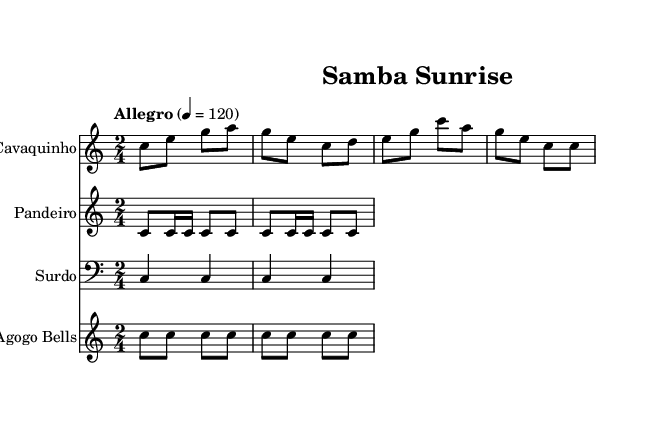What is the key signature of this music? The key signature is C major, which has no sharps or flats.
Answer: C major What is the time signature of this music? The time signature is indicated at the beginning of the score and is 2/4, meaning there are 2 beats per measure and the quarter note gets one beat.
Answer: 2/4 What is the tempo marking for this piece? The tempo marking is found right above the staff and it indicates "Allegro," specifying a fast tempo. The metronome marking is 120 beats per minute.
Answer: Allegro How many measures are in the Cavaquinho music section? To find this, count the distinct sets of notes between the vertical lines (bars); there are 4 measures in the Cavaquinho section.
Answer: 4 Which instruments are included in this piece? By looking at the headers of each staff, the instruments listed are Cavaquinho, Pandeiro, Surdo, and Agogo Bells.
Answer: Cavaquinho, Pandeiro, Surdo, Agogo Bells How is the rhythm characterized in this piece? The rhythm is indicated by the time signature and the note values; it features a lively, syncopated feel typical of samba music, with faster eighth notes and quarter notes.
Answer: Upbeat What style of music is represented in this sheet? The style is unique to the Brazilian samba genre, characterized by its energetic and lively rhythm, suitable for morning commutes.
Answer: Samba 